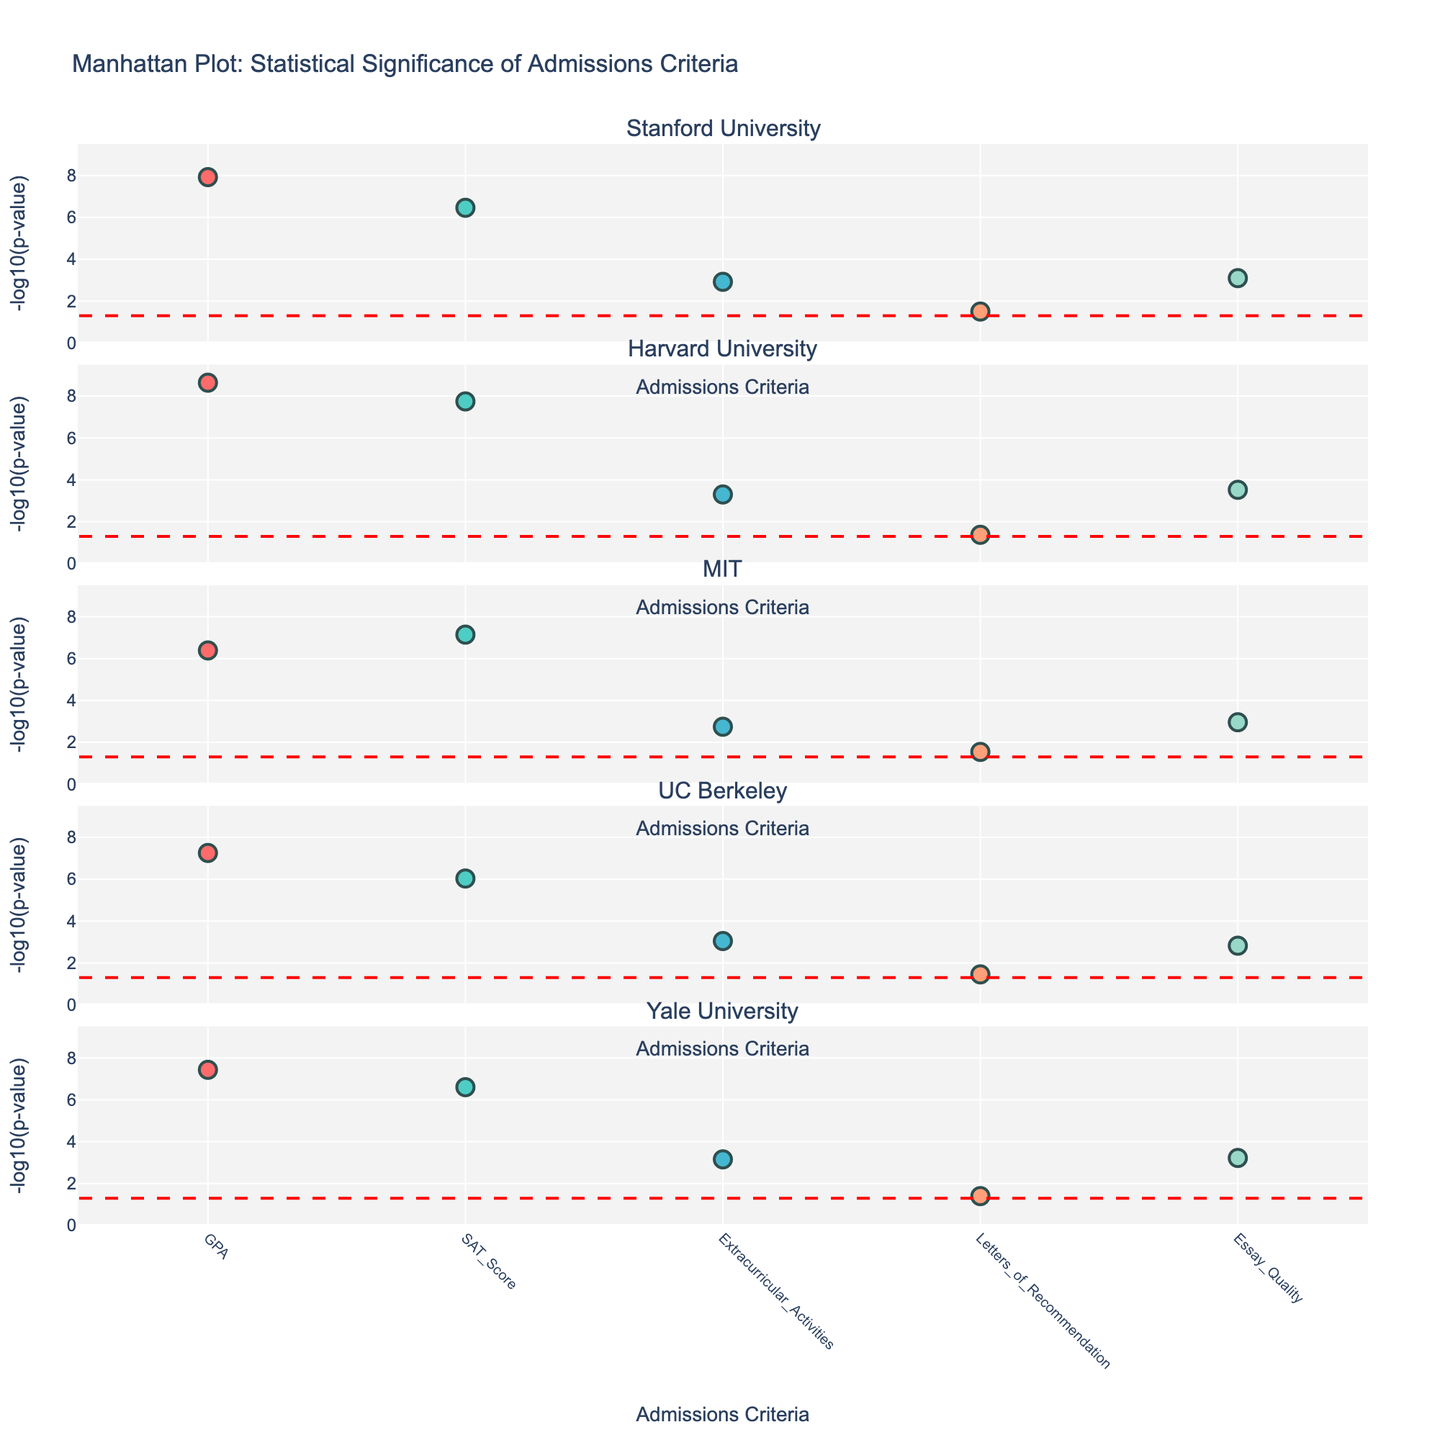How many different universities are represented in the plot? By examining the subplot titles, we see that there are five universities: Stanford University, Harvard University, MIT, UC Berkeley, and Yale University.
Answer: Five Which university has the lowest p-value for GPA as a criterion? By looking at the plot, one can identify that Harvard University has the highest -log10(p-value) for GPA, which implies the lowest p-value for this criterion.
Answer: Harvard University What is the significance threshold indicated in the plot? The horizontal dashed red line across all subplots indicates the significance threshold, which corresponds to a p-value of 0.05. In -log10(p-value) terms, this is -log10(0.05).
Answer: -log10(0.05) Which admissions criterion consistently shows high statistical significance across all universities? Observing the plot across all subplots, GPA consistently has the highest -log10(p-value) values among the criteria across all universities, indicating high statistical significance.
Answer: GPA For Stanford University, compare the statistical significance of Extracurricular Activities and Essay Quality. Which one is more significant? In the Stanford subplot, we compare the -log10(p-value) for Extracurricular Activities and Essay Quality. Essay Quality has a higher -log10(p-value) than Extracurricular Activities, indicating it is more statistically significant.
Answer: Essay Quality What is the p-value for SAT Scores in MIT, and how does it compare to the significance threshold? The plot shows the -log10(p-value) for SAT Scores in MIT. By converting -log10(7.2e-08) we see it is much higher than the threshold of -log10(0.05).
Answer: Much higher than the threshold Which university has the most similar -log10(p-value) values for Extracurricular Activities and Essay Quality? By comparing the plots, UC Berkeley has very close -log10(p-value) values for Extracurricular Activities and Essay Quality, indicating similar levels of statistical significance.
Answer: UC Berkeley How many criteria in Yale University have a -log10(p-value) higher than 3? By observing Yale University's subplot, we count the criteria above -log10(p-value) of 3. GPA, SAT Scores, Extracurricular Activities, and Essay Quality are all above this threshold.
Answer: Four Which admissions criterion in Harvard University is closest to the significance threshold? Observing Harvard's subplot, Letters of Recommendation is closest to the significance threshold line, with its -log10(p-value) just above the red dashed line.
Answer: Letters of Recommendation 